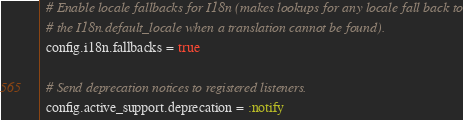Convert code to text. <code><loc_0><loc_0><loc_500><loc_500><_Ruby_>
  # Enable locale fallbacks for I18n (makes lookups for any locale fall back to
  # the I18n.default_locale when a translation cannot be found).
  config.i18n.fallbacks = true

  # Send deprecation notices to registered listeners.
  config.active_support.deprecation = :notify
</code> 